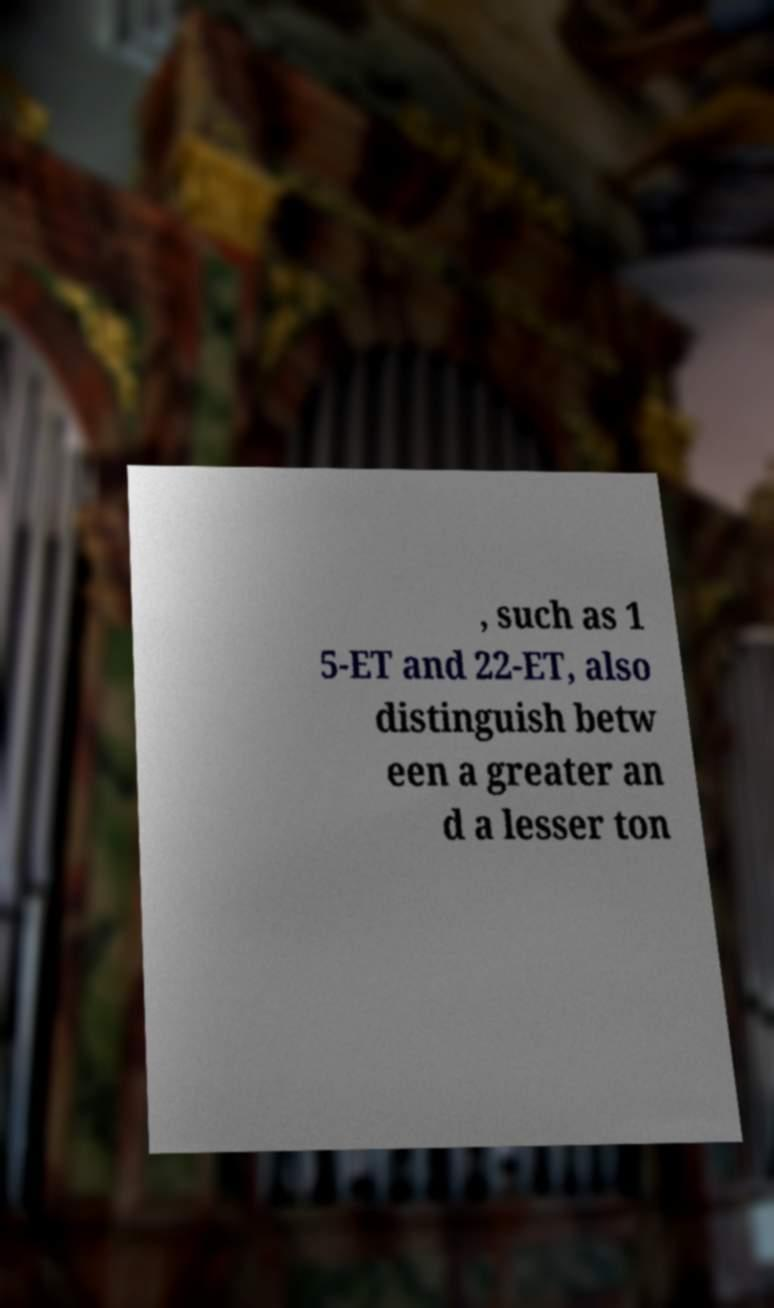Can you read and provide the text displayed in the image?This photo seems to have some interesting text. Can you extract and type it out for me? , such as 1 5-ET and 22-ET, also distinguish betw een a greater an d a lesser ton 